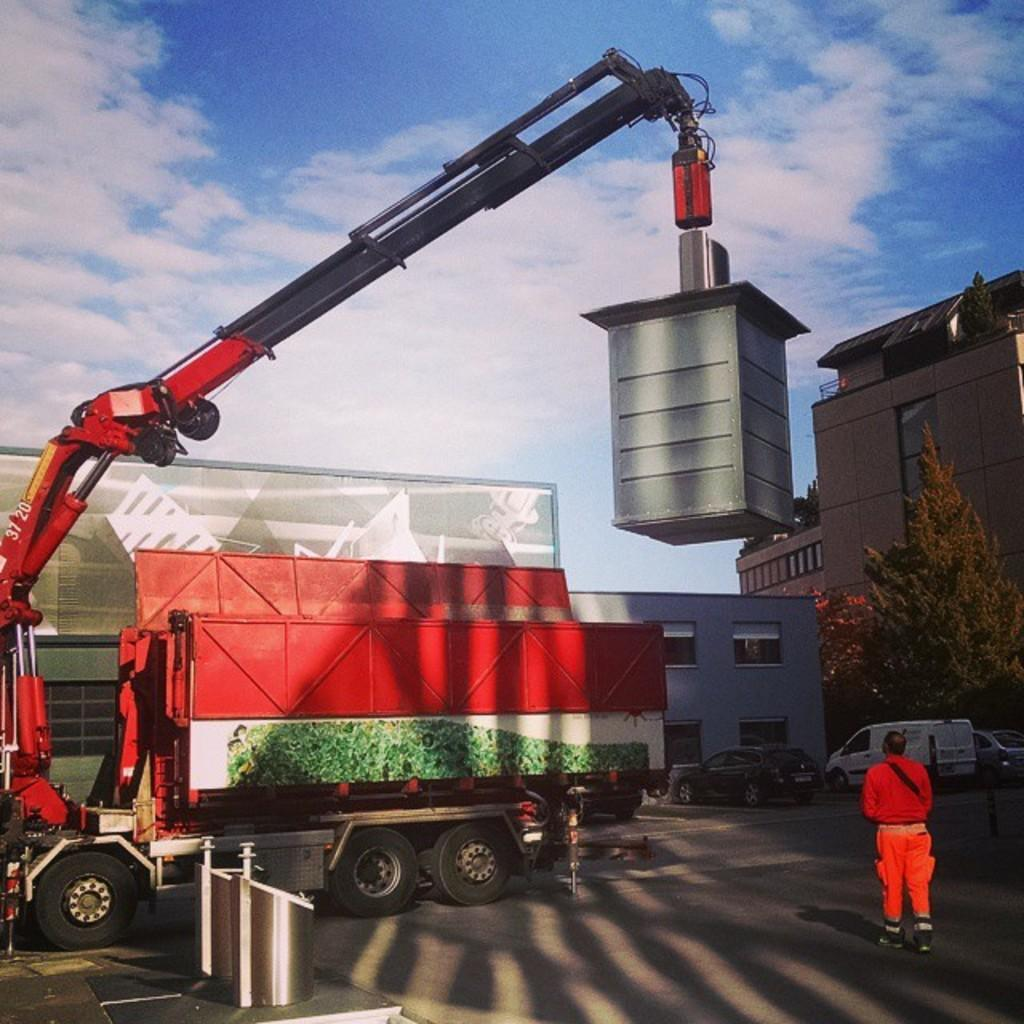Provide a one-sentence caption for the provided image. A red crane with the numbers 37 20 on it is lifting a heavy object. 